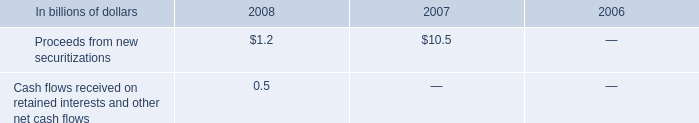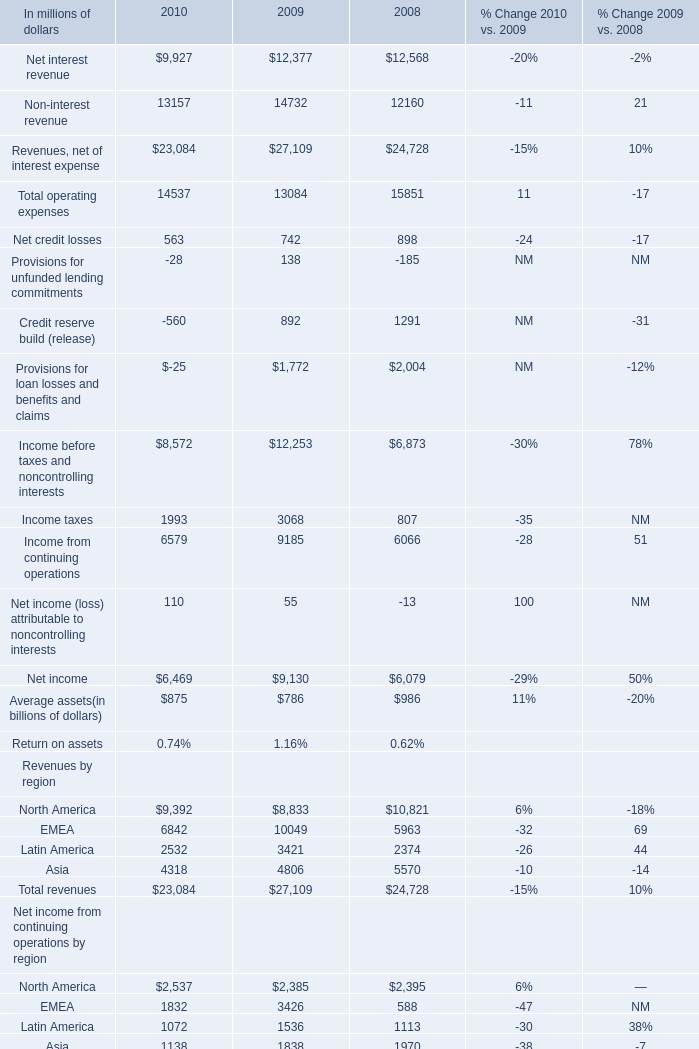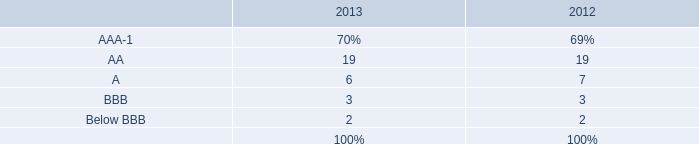What's the increasing rate of Net interest revenue in 2009? 
Computations: ((12377 - 12568) / 12568)
Answer: -0.0152. What's the total amount of Net interest revenue, Non-interest revenue, Revenues, net of interest expense and Total operating expenses in 2010? (in million) 
Computations: (((9927 + 13157) + 23084) + 14537)
Answer: 60705.0. 